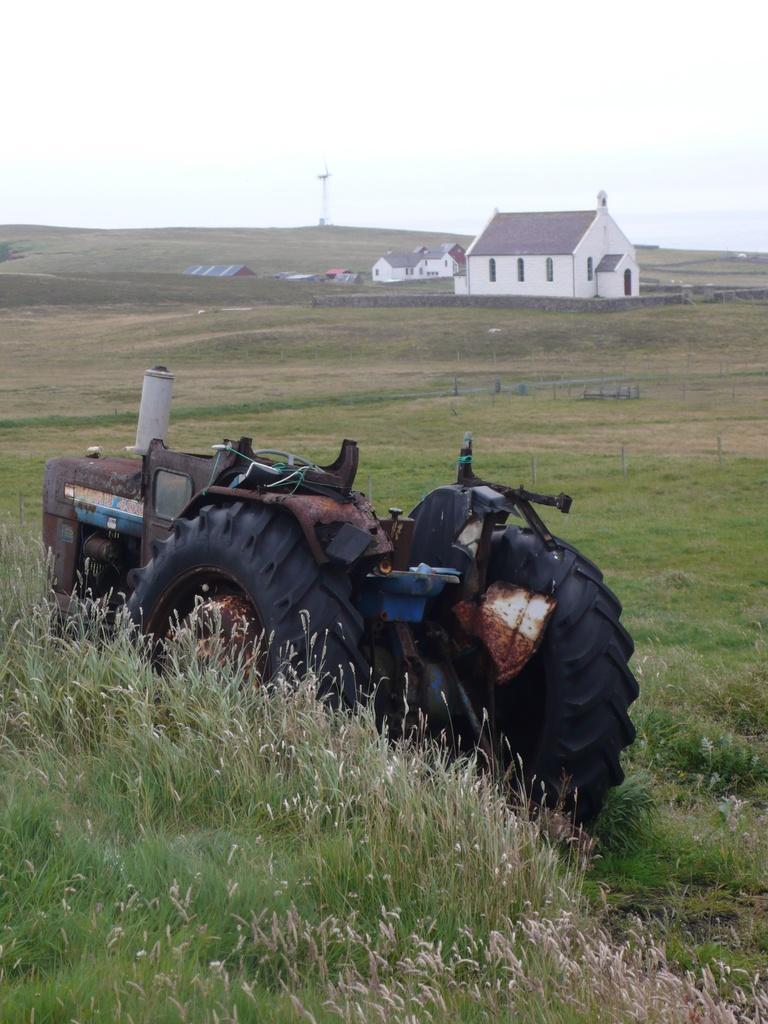Could you give a brief overview of what you see in this image? In this picture we can see a vehicle on the ground, here we can see grass, houses, pole and we can see sky in the background. 